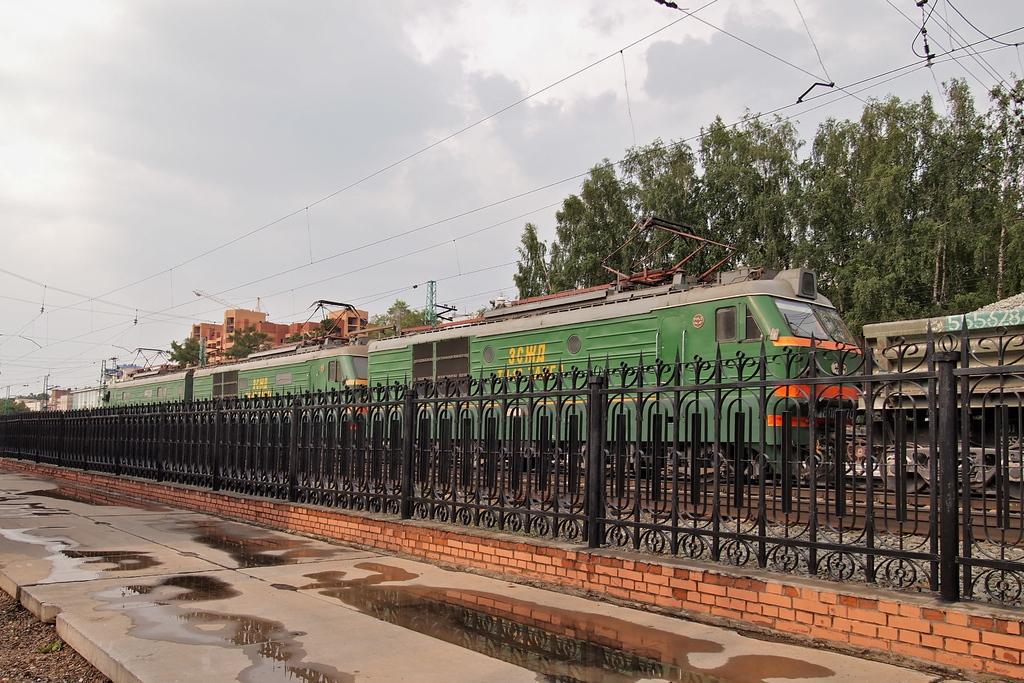Please provide a concise description of this image. This image is taken outdoors. At the top of the image there is a sky with clouds. At the bottom of the image there is a platform. In the middle of the image there is a railing and a train is moving on the track. In the background there are a few trees and poles with a few wires. There are a few buildings. 